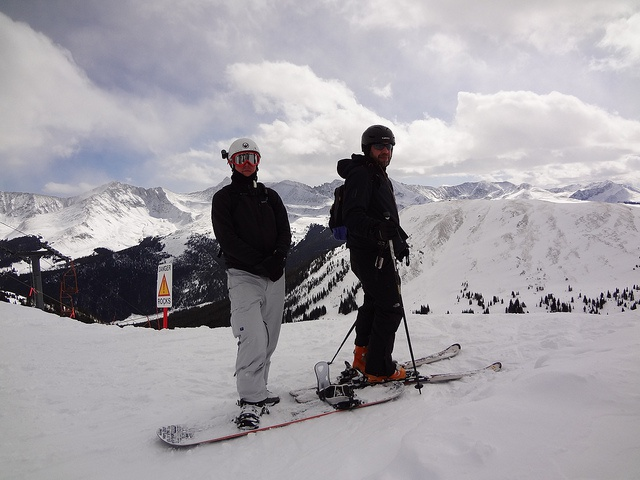Describe the objects in this image and their specific colors. I can see people in gray, black, darkgray, and maroon tones, people in gray, black, maroon, and darkgray tones, snowboard in gray, darkgray, black, and maroon tones, backpack in gray, black, lightgray, and darkgray tones, and skis in gray, darkgray, and black tones in this image. 